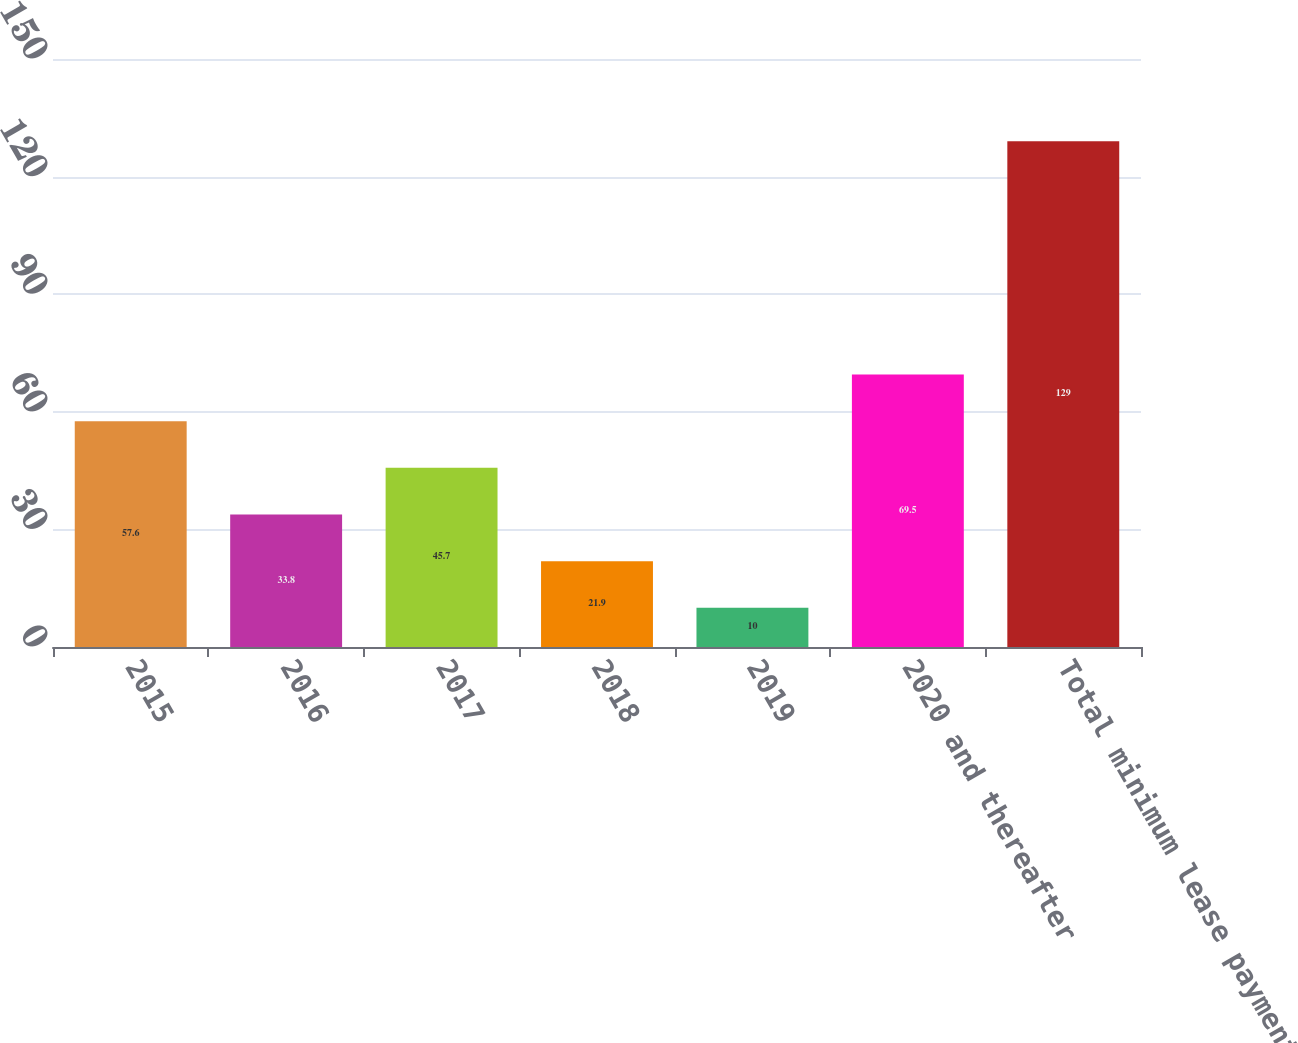<chart> <loc_0><loc_0><loc_500><loc_500><bar_chart><fcel>2015<fcel>2016<fcel>2017<fcel>2018<fcel>2019<fcel>2020 and thereafter<fcel>Total minimum lease payments<nl><fcel>57.6<fcel>33.8<fcel>45.7<fcel>21.9<fcel>10<fcel>69.5<fcel>129<nl></chart> 